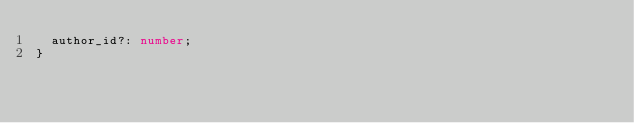Convert code to text. <code><loc_0><loc_0><loc_500><loc_500><_TypeScript_>  author_id?: number;
}
</code> 